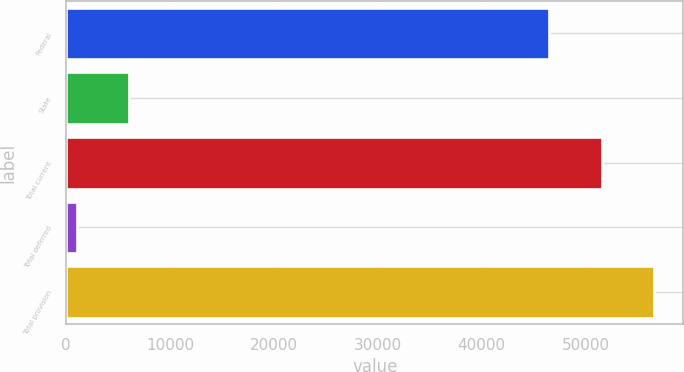<chart> <loc_0><loc_0><loc_500><loc_500><bar_chart><fcel>Federal<fcel>State<fcel>Total current<fcel>Total deferred<fcel>Total provision<nl><fcel>46489<fcel>6070.4<fcel>51537.4<fcel>1022<fcel>56585.8<nl></chart> 